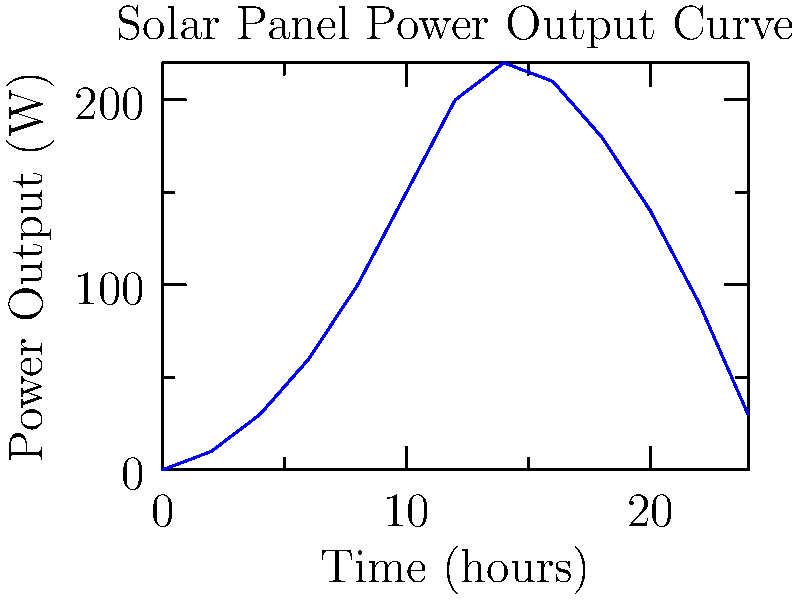As a crop producer looking to integrate solar power into your farm operations, you're analyzing the power output curve of a solar panel throughout a day. The graph shows the power output in watts versus time in hours. What is the maximum power output of the solar panel, and at approximately what time does it occur? To answer this question, we need to analyze the given power output curve:

1. Examine the y-axis (Power Output) to find the highest point on the curve.
2. The highest point on the curve represents the maximum power output.
3. From the graph, we can see that the maximum power output is 220 W.
4. To determine the time at which this occurs, we need to find the corresponding x-axis value.
5. The peak of the curve appears to be at 14 hours (2 PM) on the x-axis.

Therefore, the maximum power output is 220 W, occurring at approximately 14 hours (2 PM).

This information is crucial for an Argentine crop producer considering solar power integration:
- It helps in understanding the peak energy production time.
- Assists in planning energy-intensive farm activities around peak solar output.
- Aids in determining the number of panels needed to meet specific power requirements.
- Helps in estimating daily energy production for biofuel processing or other farm operations.
Answer: 220 W at 14 hours (2 PM) 